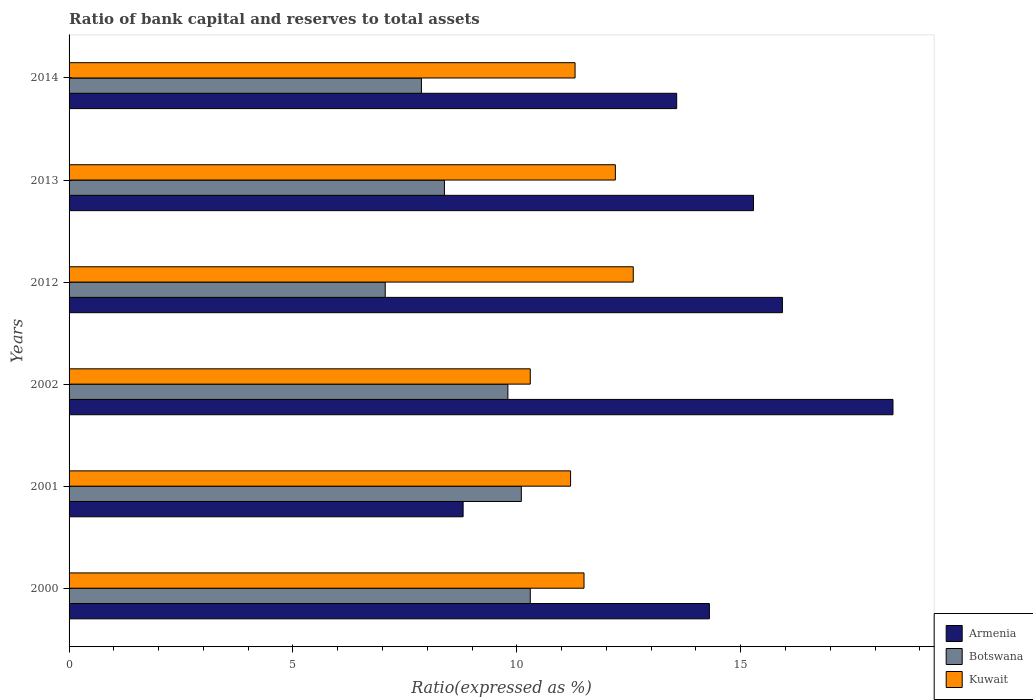How many different coloured bars are there?
Give a very brief answer. 3. Are the number of bars per tick equal to the number of legend labels?
Your response must be concise. Yes. What is the label of the 6th group of bars from the top?
Your answer should be very brief. 2000. What is the ratio of bank capital and reserves to total assets in Armenia in 2001?
Make the answer very short. 8.8. Across all years, what is the maximum ratio of bank capital and reserves to total assets in Armenia?
Offer a very short reply. 18.4. Across all years, what is the minimum ratio of bank capital and reserves to total assets in Botswana?
Keep it short and to the point. 7.06. In which year was the ratio of bank capital and reserves to total assets in Botswana maximum?
Your response must be concise. 2000. In which year was the ratio of bank capital and reserves to total assets in Kuwait minimum?
Your response must be concise. 2002. What is the total ratio of bank capital and reserves to total assets in Armenia in the graph?
Provide a short and direct response. 86.28. What is the difference between the ratio of bank capital and reserves to total assets in Kuwait in 2001 and that in 2014?
Give a very brief answer. -0.1. What is the difference between the ratio of bank capital and reserves to total assets in Kuwait in 2014 and the ratio of bank capital and reserves to total assets in Botswana in 2013?
Your answer should be very brief. 2.92. What is the average ratio of bank capital and reserves to total assets in Botswana per year?
Provide a short and direct response. 8.92. In the year 2012, what is the difference between the ratio of bank capital and reserves to total assets in Botswana and ratio of bank capital and reserves to total assets in Armenia?
Your answer should be very brief. -8.87. What is the ratio of the ratio of bank capital and reserves to total assets in Kuwait in 2012 to that in 2013?
Your answer should be very brief. 1.03. What is the difference between the highest and the second highest ratio of bank capital and reserves to total assets in Armenia?
Your answer should be compact. 2.47. What is the difference between the highest and the lowest ratio of bank capital and reserves to total assets in Botswana?
Ensure brevity in your answer.  3.24. In how many years, is the ratio of bank capital and reserves to total assets in Kuwait greater than the average ratio of bank capital and reserves to total assets in Kuwait taken over all years?
Provide a short and direct response. 2. Is the sum of the ratio of bank capital and reserves to total assets in Kuwait in 2000 and 2002 greater than the maximum ratio of bank capital and reserves to total assets in Armenia across all years?
Your response must be concise. Yes. What does the 1st bar from the top in 2001 represents?
Offer a very short reply. Kuwait. What does the 3rd bar from the bottom in 2013 represents?
Provide a succinct answer. Kuwait. Is it the case that in every year, the sum of the ratio of bank capital and reserves to total assets in Botswana and ratio of bank capital and reserves to total assets in Armenia is greater than the ratio of bank capital and reserves to total assets in Kuwait?
Make the answer very short. Yes. How many bars are there?
Make the answer very short. 18. Are all the bars in the graph horizontal?
Offer a terse response. Yes. How many years are there in the graph?
Ensure brevity in your answer.  6. Are the values on the major ticks of X-axis written in scientific E-notation?
Your answer should be very brief. No. Where does the legend appear in the graph?
Provide a succinct answer. Bottom right. What is the title of the graph?
Ensure brevity in your answer.  Ratio of bank capital and reserves to total assets. Does "Latvia" appear as one of the legend labels in the graph?
Ensure brevity in your answer.  No. What is the label or title of the X-axis?
Give a very brief answer. Ratio(expressed as %). What is the label or title of the Y-axis?
Make the answer very short. Years. What is the Ratio(expressed as %) of Armenia in 2000?
Ensure brevity in your answer.  14.3. What is the Ratio(expressed as %) in Kuwait in 2000?
Offer a very short reply. 11.5. What is the Ratio(expressed as %) in Kuwait in 2001?
Keep it short and to the point. 11.2. What is the Ratio(expressed as %) of Armenia in 2012?
Give a very brief answer. 15.93. What is the Ratio(expressed as %) in Botswana in 2012?
Your answer should be very brief. 7.06. What is the Ratio(expressed as %) of Armenia in 2013?
Provide a short and direct response. 15.28. What is the Ratio(expressed as %) in Botswana in 2013?
Provide a succinct answer. 8.38. What is the Ratio(expressed as %) of Armenia in 2014?
Provide a succinct answer. 13.57. What is the Ratio(expressed as %) of Botswana in 2014?
Ensure brevity in your answer.  7.87. Across all years, what is the minimum Ratio(expressed as %) of Botswana?
Your response must be concise. 7.06. What is the total Ratio(expressed as %) of Armenia in the graph?
Give a very brief answer. 86.28. What is the total Ratio(expressed as %) of Botswana in the graph?
Offer a very short reply. 53.51. What is the total Ratio(expressed as %) in Kuwait in the graph?
Provide a succinct answer. 69.1. What is the difference between the Ratio(expressed as %) in Botswana in 2000 and that in 2001?
Give a very brief answer. 0.2. What is the difference between the Ratio(expressed as %) of Armenia in 2000 and that in 2012?
Offer a terse response. -1.63. What is the difference between the Ratio(expressed as %) of Botswana in 2000 and that in 2012?
Ensure brevity in your answer.  3.24. What is the difference between the Ratio(expressed as %) of Armenia in 2000 and that in 2013?
Your response must be concise. -0.98. What is the difference between the Ratio(expressed as %) of Botswana in 2000 and that in 2013?
Your answer should be very brief. 1.92. What is the difference between the Ratio(expressed as %) of Kuwait in 2000 and that in 2013?
Your answer should be very brief. -0.7. What is the difference between the Ratio(expressed as %) of Armenia in 2000 and that in 2014?
Provide a short and direct response. 0.73. What is the difference between the Ratio(expressed as %) in Botswana in 2000 and that in 2014?
Your answer should be compact. 2.43. What is the difference between the Ratio(expressed as %) in Kuwait in 2000 and that in 2014?
Make the answer very short. 0.2. What is the difference between the Ratio(expressed as %) of Armenia in 2001 and that in 2002?
Provide a short and direct response. -9.6. What is the difference between the Ratio(expressed as %) of Armenia in 2001 and that in 2012?
Give a very brief answer. -7.13. What is the difference between the Ratio(expressed as %) of Botswana in 2001 and that in 2012?
Offer a terse response. 3.04. What is the difference between the Ratio(expressed as %) of Kuwait in 2001 and that in 2012?
Give a very brief answer. -1.4. What is the difference between the Ratio(expressed as %) in Armenia in 2001 and that in 2013?
Offer a very short reply. -6.48. What is the difference between the Ratio(expressed as %) of Botswana in 2001 and that in 2013?
Make the answer very short. 1.72. What is the difference between the Ratio(expressed as %) in Kuwait in 2001 and that in 2013?
Your response must be concise. -1. What is the difference between the Ratio(expressed as %) of Armenia in 2001 and that in 2014?
Your answer should be compact. -4.77. What is the difference between the Ratio(expressed as %) in Botswana in 2001 and that in 2014?
Your answer should be very brief. 2.23. What is the difference between the Ratio(expressed as %) of Kuwait in 2001 and that in 2014?
Ensure brevity in your answer.  -0.1. What is the difference between the Ratio(expressed as %) in Armenia in 2002 and that in 2012?
Provide a short and direct response. 2.47. What is the difference between the Ratio(expressed as %) in Botswana in 2002 and that in 2012?
Your answer should be compact. 2.74. What is the difference between the Ratio(expressed as %) of Kuwait in 2002 and that in 2012?
Make the answer very short. -2.3. What is the difference between the Ratio(expressed as %) of Armenia in 2002 and that in 2013?
Offer a terse response. 3.12. What is the difference between the Ratio(expressed as %) of Botswana in 2002 and that in 2013?
Your answer should be compact. 1.42. What is the difference between the Ratio(expressed as %) of Kuwait in 2002 and that in 2013?
Make the answer very short. -1.9. What is the difference between the Ratio(expressed as %) in Armenia in 2002 and that in 2014?
Provide a succinct answer. 4.83. What is the difference between the Ratio(expressed as %) in Botswana in 2002 and that in 2014?
Your answer should be very brief. 1.93. What is the difference between the Ratio(expressed as %) of Armenia in 2012 and that in 2013?
Keep it short and to the point. 0.65. What is the difference between the Ratio(expressed as %) in Botswana in 2012 and that in 2013?
Make the answer very short. -1.32. What is the difference between the Ratio(expressed as %) in Armenia in 2012 and that in 2014?
Offer a very short reply. 2.36. What is the difference between the Ratio(expressed as %) of Botswana in 2012 and that in 2014?
Keep it short and to the point. -0.81. What is the difference between the Ratio(expressed as %) of Kuwait in 2012 and that in 2014?
Your answer should be compact. 1.3. What is the difference between the Ratio(expressed as %) of Armenia in 2013 and that in 2014?
Give a very brief answer. 1.71. What is the difference between the Ratio(expressed as %) of Botswana in 2013 and that in 2014?
Your response must be concise. 0.51. What is the difference between the Ratio(expressed as %) of Armenia in 2000 and the Ratio(expressed as %) of Kuwait in 2001?
Offer a very short reply. 3.1. What is the difference between the Ratio(expressed as %) in Armenia in 2000 and the Ratio(expressed as %) in Botswana in 2002?
Give a very brief answer. 4.5. What is the difference between the Ratio(expressed as %) of Armenia in 2000 and the Ratio(expressed as %) of Kuwait in 2002?
Provide a short and direct response. 4. What is the difference between the Ratio(expressed as %) in Armenia in 2000 and the Ratio(expressed as %) in Botswana in 2012?
Make the answer very short. 7.24. What is the difference between the Ratio(expressed as %) of Armenia in 2000 and the Ratio(expressed as %) of Botswana in 2013?
Provide a succinct answer. 5.92. What is the difference between the Ratio(expressed as %) of Botswana in 2000 and the Ratio(expressed as %) of Kuwait in 2013?
Provide a succinct answer. -1.9. What is the difference between the Ratio(expressed as %) in Armenia in 2000 and the Ratio(expressed as %) in Botswana in 2014?
Provide a succinct answer. 6.43. What is the difference between the Ratio(expressed as %) of Armenia in 2000 and the Ratio(expressed as %) of Kuwait in 2014?
Offer a terse response. 3. What is the difference between the Ratio(expressed as %) of Armenia in 2001 and the Ratio(expressed as %) of Botswana in 2012?
Keep it short and to the point. 1.74. What is the difference between the Ratio(expressed as %) of Armenia in 2001 and the Ratio(expressed as %) of Botswana in 2013?
Offer a very short reply. 0.42. What is the difference between the Ratio(expressed as %) of Armenia in 2001 and the Ratio(expressed as %) of Botswana in 2014?
Ensure brevity in your answer.  0.93. What is the difference between the Ratio(expressed as %) in Botswana in 2001 and the Ratio(expressed as %) in Kuwait in 2014?
Provide a short and direct response. -1.2. What is the difference between the Ratio(expressed as %) in Armenia in 2002 and the Ratio(expressed as %) in Botswana in 2012?
Offer a very short reply. 11.34. What is the difference between the Ratio(expressed as %) of Armenia in 2002 and the Ratio(expressed as %) of Kuwait in 2012?
Keep it short and to the point. 5.8. What is the difference between the Ratio(expressed as %) in Armenia in 2002 and the Ratio(expressed as %) in Botswana in 2013?
Ensure brevity in your answer.  10.02. What is the difference between the Ratio(expressed as %) in Armenia in 2002 and the Ratio(expressed as %) in Kuwait in 2013?
Make the answer very short. 6.2. What is the difference between the Ratio(expressed as %) of Armenia in 2002 and the Ratio(expressed as %) of Botswana in 2014?
Provide a short and direct response. 10.53. What is the difference between the Ratio(expressed as %) of Armenia in 2002 and the Ratio(expressed as %) of Kuwait in 2014?
Offer a terse response. 7.1. What is the difference between the Ratio(expressed as %) in Armenia in 2012 and the Ratio(expressed as %) in Botswana in 2013?
Your answer should be compact. 7.55. What is the difference between the Ratio(expressed as %) in Armenia in 2012 and the Ratio(expressed as %) in Kuwait in 2013?
Provide a succinct answer. 3.73. What is the difference between the Ratio(expressed as %) of Botswana in 2012 and the Ratio(expressed as %) of Kuwait in 2013?
Make the answer very short. -5.14. What is the difference between the Ratio(expressed as %) of Armenia in 2012 and the Ratio(expressed as %) of Botswana in 2014?
Your answer should be very brief. 8.06. What is the difference between the Ratio(expressed as %) of Armenia in 2012 and the Ratio(expressed as %) of Kuwait in 2014?
Your answer should be very brief. 4.63. What is the difference between the Ratio(expressed as %) of Botswana in 2012 and the Ratio(expressed as %) of Kuwait in 2014?
Offer a very short reply. -4.24. What is the difference between the Ratio(expressed as %) of Armenia in 2013 and the Ratio(expressed as %) of Botswana in 2014?
Ensure brevity in your answer.  7.42. What is the difference between the Ratio(expressed as %) in Armenia in 2013 and the Ratio(expressed as %) in Kuwait in 2014?
Your answer should be compact. 3.98. What is the difference between the Ratio(expressed as %) of Botswana in 2013 and the Ratio(expressed as %) of Kuwait in 2014?
Give a very brief answer. -2.92. What is the average Ratio(expressed as %) in Armenia per year?
Provide a short and direct response. 14.38. What is the average Ratio(expressed as %) of Botswana per year?
Your answer should be compact. 8.92. What is the average Ratio(expressed as %) of Kuwait per year?
Ensure brevity in your answer.  11.52. In the year 2000, what is the difference between the Ratio(expressed as %) in Botswana and Ratio(expressed as %) in Kuwait?
Make the answer very short. -1.2. In the year 2001, what is the difference between the Ratio(expressed as %) in Armenia and Ratio(expressed as %) in Botswana?
Your response must be concise. -1.3. In the year 2001, what is the difference between the Ratio(expressed as %) in Armenia and Ratio(expressed as %) in Kuwait?
Your answer should be compact. -2.4. In the year 2002, what is the difference between the Ratio(expressed as %) of Armenia and Ratio(expressed as %) of Kuwait?
Offer a terse response. 8.1. In the year 2002, what is the difference between the Ratio(expressed as %) of Botswana and Ratio(expressed as %) of Kuwait?
Your answer should be compact. -0.5. In the year 2012, what is the difference between the Ratio(expressed as %) in Armenia and Ratio(expressed as %) in Botswana?
Your answer should be compact. 8.87. In the year 2012, what is the difference between the Ratio(expressed as %) of Armenia and Ratio(expressed as %) of Kuwait?
Offer a very short reply. 3.33. In the year 2012, what is the difference between the Ratio(expressed as %) of Botswana and Ratio(expressed as %) of Kuwait?
Ensure brevity in your answer.  -5.54. In the year 2013, what is the difference between the Ratio(expressed as %) in Armenia and Ratio(expressed as %) in Botswana?
Provide a succinct answer. 6.9. In the year 2013, what is the difference between the Ratio(expressed as %) in Armenia and Ratio(expressed as %) in Kuwait?
Make the answer very short. 3.08. In the year 2013, what is the difference between the Ratio(expressed as %) in Botswana and Ratio(expressed as %) in Kuwait?
Provide a succinct answer. -3.82. In the year 2014, what is the difference between the Ratio(expressed as %) in Armenia and Ratio(expressed as %) in Botswana?
Offer a terse response. 5.7. In the year 2014, what is the difference between the Ratio(expressed as %) in Armenia and Ratio(expressed as %) in Kuwait?
Your response must be concise. 2.27. In the year 2014, what is the difference between the Ratio(expressed as %) in Botswana and Ratio(expressed as %) in Kuwait?
Your answer should be very brief. -3.43. What is the ratio of the Ratio(expressed as %) in Armenia in 2000 to that in 2001?
Ensure brevity in your answer.  1.62. What is the ratio of the Ratio(expressed as %) of Botswana in 2000 to that in 2001?
Provide a succinct answer. 1.02. What is the ratio of the Ratio(expressed as %) of Kuwait in 2000 to that in 2001?
Ensure brevity in your answer.  1.03. What is the ratio of the Ratio(expressed as %) in Armenia in 2000 to that in 2002?
Provide a short and direct response. 0.78. What is the ratio of the Ratio(expressed as %) in Botswana in 2000 to that in 2002?
Give a very brief answer. 1.05. What is the ratio of the Ratio(expressed as %) of Kuwait in 2000 to that in 2002?
Provide a succinct answer. 1.12. What is the ratio of the Ratio(expressed as %) in Armenia in 2000 to that in 2012?
Keep it short and to the point. 0.9. What is the ratio of the Ratio(expressed as %) of Botswana in 2000 to that in 2012?
Keep it short and to the point. 1.46. What is the ratio of the Ratio(expressed as %) of Kuwait in 2000 to that in 2012?
Ensure brevity in your answer.  0.91. What is the ratio of the Ratio(expressed as %) in Armenia in 2000 to that in 2013?
Make the answer very short. 0.94. What is the ratio of the Ratio(expressed as %) of Botswana in 2000 to that in 2013?
Ensure brevity in your answer.  1.23. What is the ratio of the Ratio(expressed as %) in Kuwait in 2000 to that in 2013?
Offer a terse response. 0.94. What is the ratio of the Ratio(expressed as %) of Armenia in 2000 to that in 2014?
Ensure brevity in your answer.  1.05. What is the ratio of the Ratio(expressed as %) in Botswana in 2000 to that in 2014?
Keep it short and to the point. 1.31. What is the ratio of the Ratio(expressed as %) in Kuwait in 2000 to that in 2014?
Give a very brief answer. 1.02. What is the ratio of the Ratio(expressed as %) of Armenia in 2001 to that in 2002?
Your answer should be very brief. 0.48. What is the ratio of the Ratio(expressed as %) in Botswana in 2001 to that in 2002?
Make the answer very short. 1.03. What is the ratio of the Ratio(expressed as %) in Kuwait in 2001 to that in 2002?
Keep it short and to the point. 1.09. What is the ratio of the Ratio(expressed as %) in Armenia in 2001 to that in 2012?
Ensure brevity in your answer.  0.55. What is the ratio of the Ratio(expressed as %) of Botswana in 2001 to that in 2012?
Make the answer very short. 1.43. What is the ratio of the Ratio(expressed as %) of Armenia in 2001 to that in 2013?
Provide a succinct answer. 0.58. What is the ratio of the Ratio(expressed as %) of Botswana in 2001 to that in 2013?
Your response must be concise. 1.2. What is the ratio of the Ratio(expressed as %) of Kuwait in 2001 to that in 2013?
Your response must be concise. 0.92. What is the ratio of the Ratio(expressed as %) of Armenia in 2001 to that in 2014?
Your answer should be compact. 0.65. What is the ratio of the Ratio(expressed as %) of Botswana in 2001 to that in 2014?
Your answer should be compact. 1.28. What is the ratio of the Ratio(expressed as %) in Kuwait in 2001 to that in 2014?
Make the answer very short. 0.99. What is the ratio of the Ratio(expressed as %) in Armenia in 2002 to that in 2012?
Offer a terse response. 1.16. What is the ratio of the Ratio(expressed as %) of Botswana in 2002 to that in 2012?
Make the answer very short. 1.39. What is the ratio of the Ratio(expressed as %) of Kuwait in 2002 to that in 2012?
Offer a very short reply. 0.82. What is the ratio of the Ratio(expressed as %) of Armenia in 2002 to that in 2013?
Offer a terse response. 1.2. What is the ratio of the Ratio(expressed as %) of Botswana in 2002 to that in 2013?
Your answer should be very brief. 1.17. What is the ratio of the Ratio(expressed as %) in Kuwait in 2002 to that in 2013?
Your response must be concise. 0.84. What is the ratio of the Ratio(expressed as %) in Armenia in 2002 to that in 2014?
Keep it short and to the point. 1.36. What is the ratio of the Ratio(expressed as %) in Botswana in 2002 to that in 2014?
Offer a very short reply. 1.25. What is the ratio of the Ratio(expressed as %) in Kuwait in 2002 to that in 2014?
Your answer should be very brief. 0.91. What is the ratio of the Ratio(expressed as %) of Armenia in 2012 to that in 2013?
Provide a short and direct response. 1.04. What is the ratio of the Ratio(expressed as %) in Botswana in 2012 to that in 2013?
Give a very brief answer. 0.84. What is the ratio of the Ratio(expressed as %) in Kuwait in 2012 to that in 2013?
Your answer should be very brief. 1.03. What is the ratio of the Ratio(expressed as %) of Armenia in 2012 to that in 2014?
Make the answer very short. 1.17. What is the ratio of the Ratio(expressed as %) of Botswana in 2012 to that in 2014?
Keep it short and to the point. 0.9. What is the ratio of the Ratio(expressed as %) in Kuwait in 2012 to that in 2014?
Provide a short and direct response. 1.11. What is the ratio of the Ratio(expressed as %) in Armenia in 2013 to that in 2014?
Ensure brevity in your answer.  1.13. What is the ratio of the Ratio(expressed as %) of Botswana in 2013 to that in 2014?
Your response must be concise. 1.07. What is the ratio of the Ratio(expressed as %) of Kuwait in 2013 to that in 2014?
Offer a very short reply. 1.08. What is the difference between the highest and the second highest Ratio(expressed as %) in Armenia?
Make the answer very short. 2.47. What is the difference between the highest and the second highest Ratio(expressed as %) of Botswana?
Keep it short and to the point. 0.2. What is the difference between the highest and the second highest Ratio(expressed as %) of Kuwait?
Your answer should be very brief. 0.4. What is the difference between the highest and the lowest Ratio(expressed as %) in Botswana?
Provide a succinct answer. 3.24. What is the difference between the highest and the lowest Ratio(expressed as %) in Kuwait?
Ensure brevity in your answer.  2.3. 